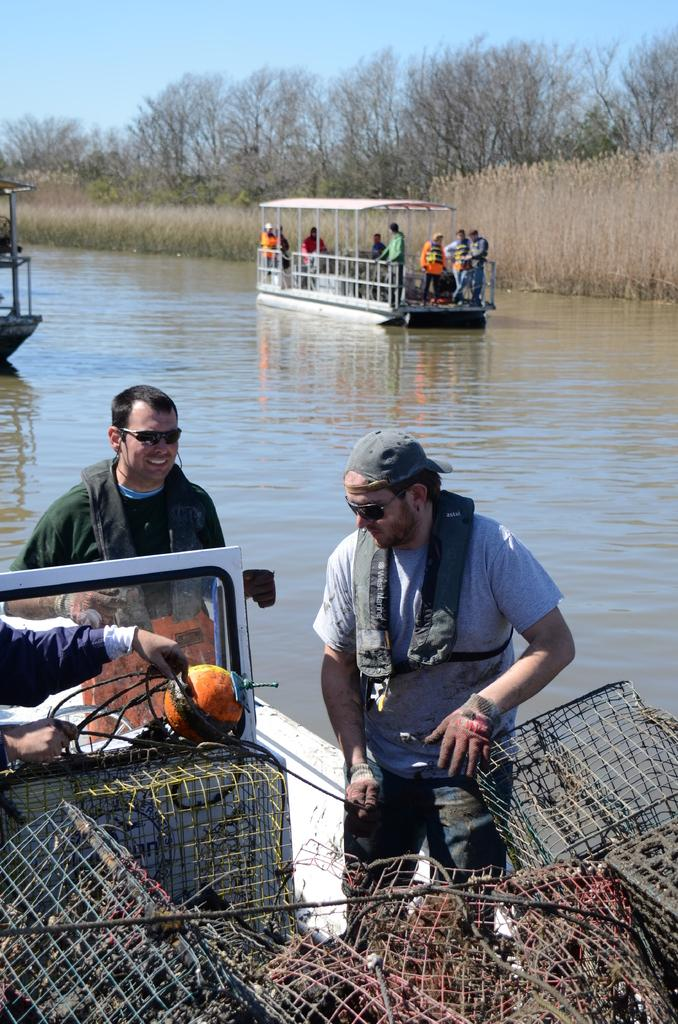What are the people in the image doing? There are persons on the boats in the image. Where are the boats located? The boats are on water. What can be seen in the background of the image? There are trees and the sky visible in the background of the image. What type of loaf is being used as a pot in the image? There is no loaf or pot present in the image. What kind of art can be seen on the boats in the image? There is no art visible on the boats in the image. 